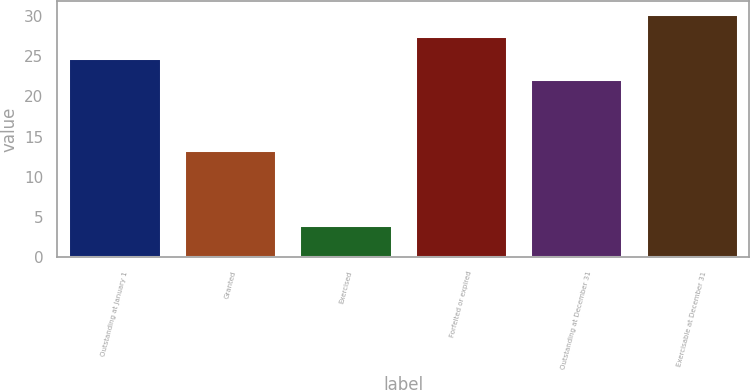Convert chart. <chart><loc_0><loc_0><loc_500><loc_500><bar_chart><fcel>Outstanding at January 1<fcel>Granted<fcel>Exercised<fcel>Forfeited or expired<fcel>Outstanding at December 31<fcel>Exercisable at December 31<nl><fcel>24.83<fcel>13.36<fcel>3.96<fcel>27.46<fcel>22.2<fcel>30.29<nl></chart> 